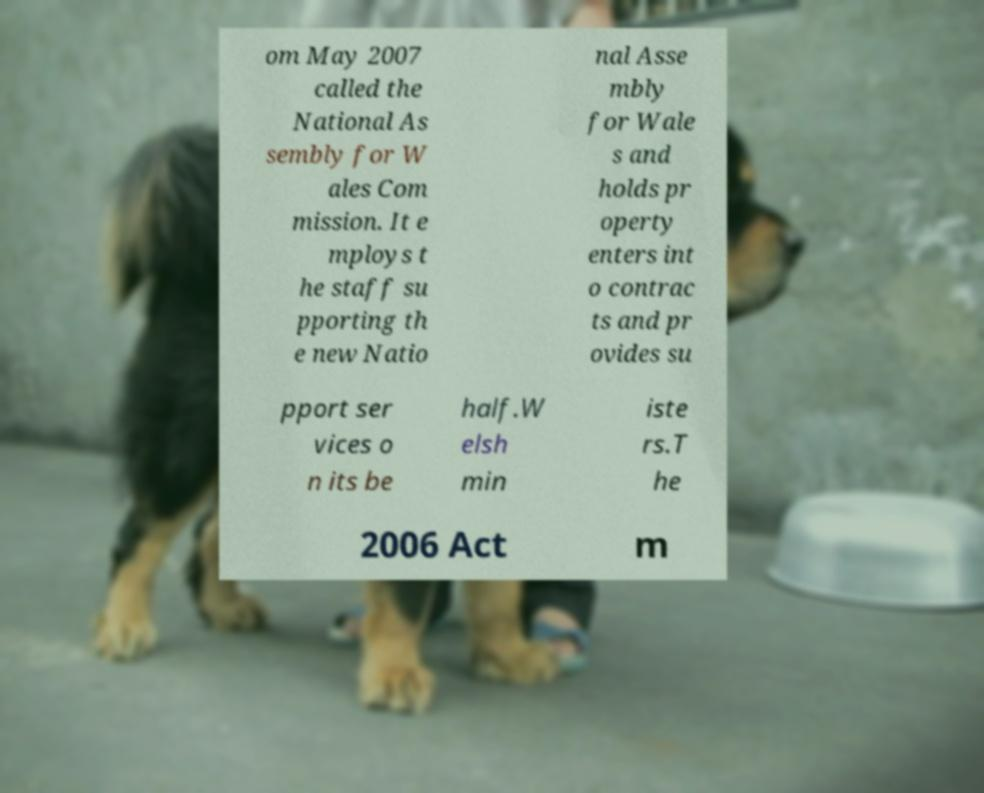Could you assist in decoding the text presented in this image and type it out clearly? om May 2007 called the National As sembly for W ales Com mission. It e mploys t he staff su pporting th e new Natio nal Asse mbly for Wale s and holds pr operty enters int o contrac ts and pr ovides su pport ser vices o n its be half.W elsh min iste rs.T he 2006 Act m 